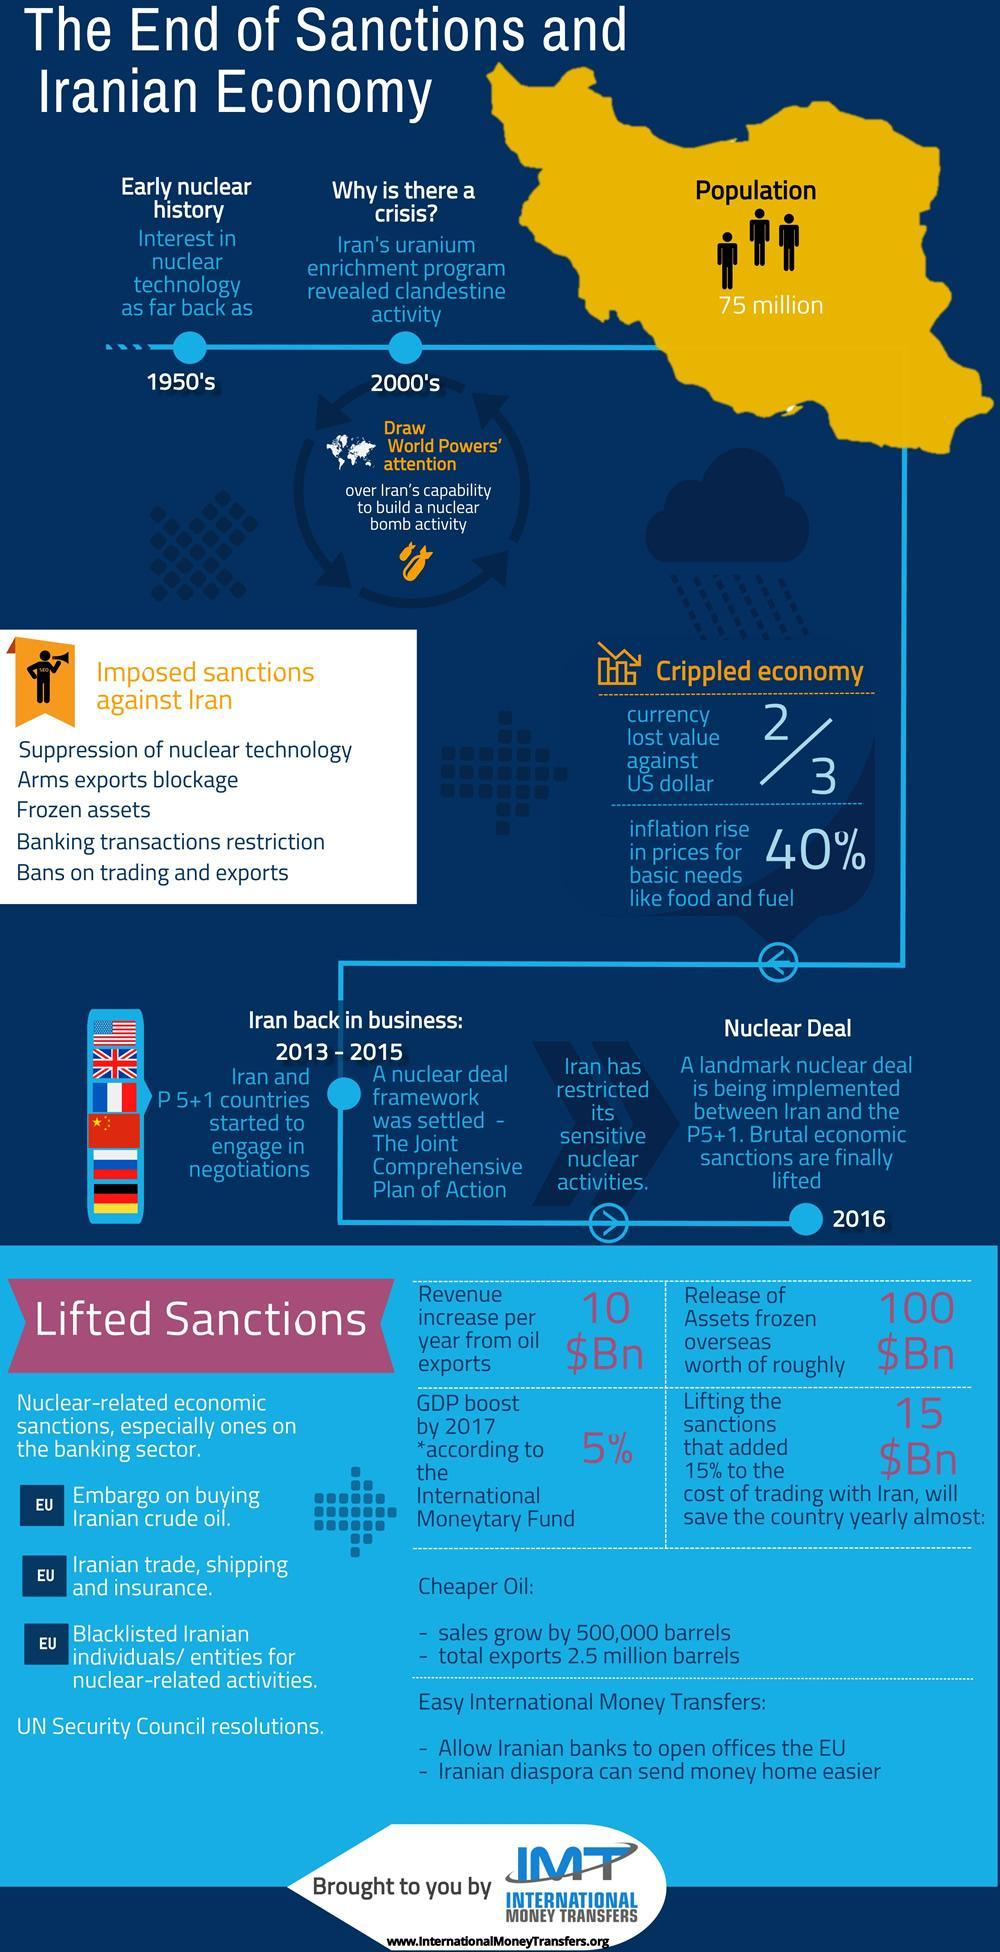During which year, Iran has restricted its sensitive nuclear activities?
Answer the question with a short phrase. 2013 - 2015 When was the nuclear deal implemented between Iran & P5+1 countries? 2016 What percentage is the GDP increase in Iran by 2017? 5% 